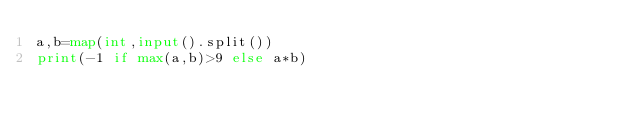Convert code to text. <code><loc_0><loc_0><loc_500><loc_500><_Python_>a,b=map(int,input().split())
print(-1 if max(a,b)>9 else a*b)</code> 